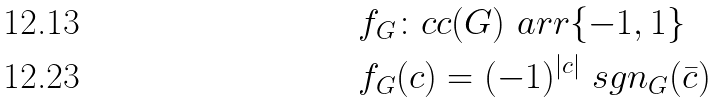Convert formula to latex. <formula><loc_0><loc_0><loc_500><loc_500>& f _ { G } \colon c c ( G ) \ a r r \{ - 1 , 1 \} \\ & f _ { G } ( c ) = ( - 1 ) ^ { | c | } \ s g n _ { G } ( \bar { c } )</formula> 